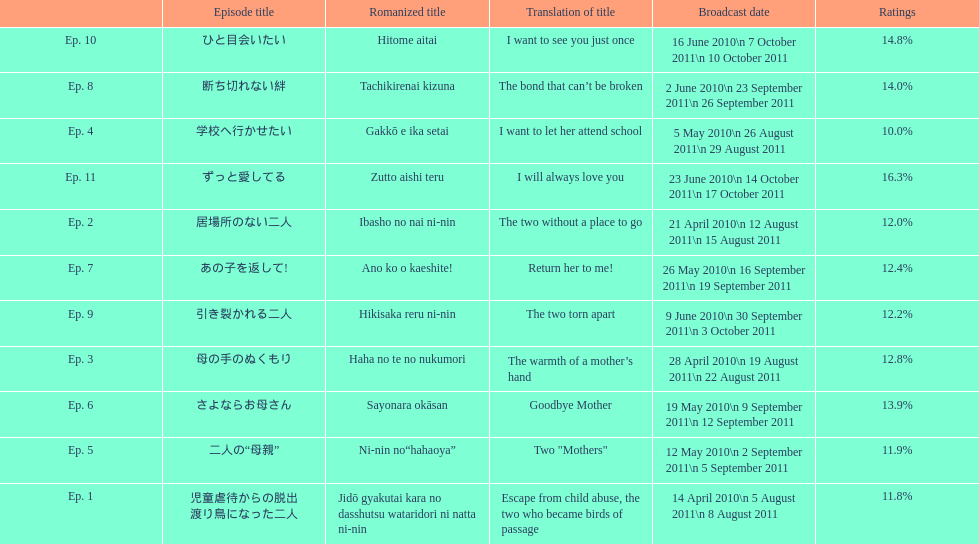What episode was called "i want to let her attend school"? Ep. 4. 